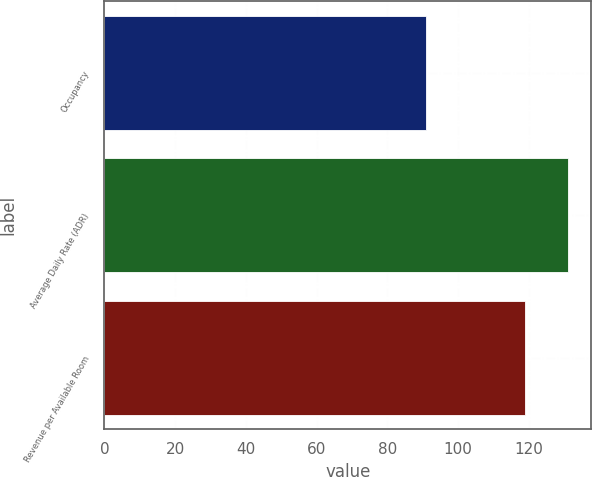<chart> <loc_0><loc_0><loc_500><loc_500><bar_chart><fcel>Occupancy<fcel>Average Daily Rate (ADR)<fcel>Revenue per Available Room<nl><fcel>91<fcel>131<fcel>119<nl></chart> 